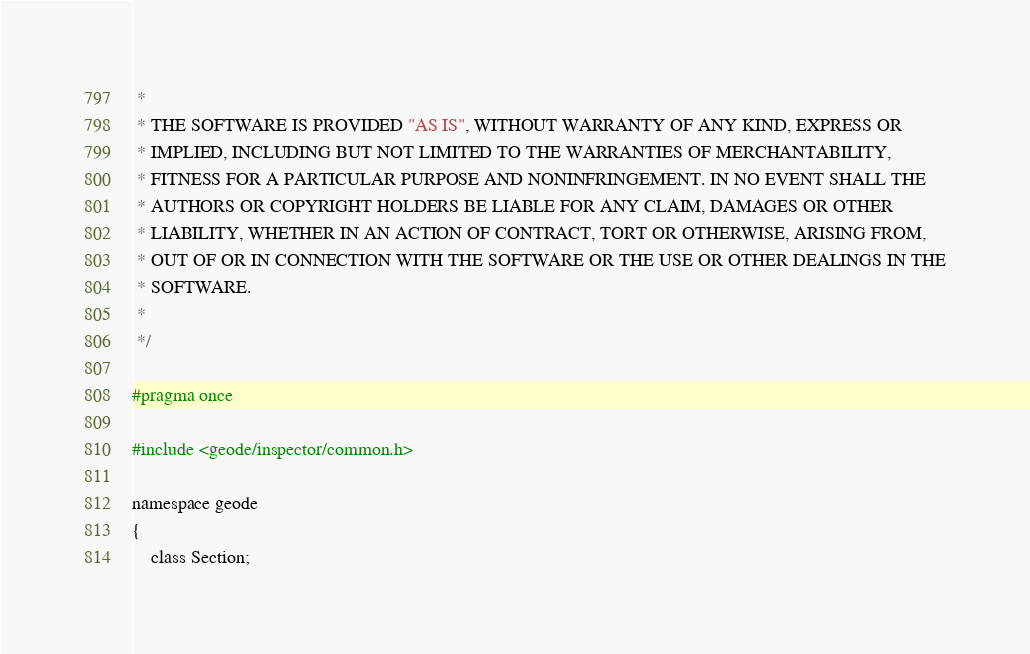Convert code to text. <code><loc_0><loc_0><loc_500><loc_500><_C_> *
 * THE SOFTWARE IS PROVIDED "AS IS", WITHOUT WARRANTY OF ANY KIND, EXPRESS OR
 * IMPLIED, INCLUDING BUT NOT LIMITED TO THE WARRANTIES OF MERCHANTABILITY,
 * FITNESS FOR A PARTICULAR PURPOSE AND NONINFRINGEMENT. IN NO EVENT SHALL THE
 * AUTHORS OR COPYRIGHT HOLDERS BE LIABLE FOR ANY CLAIM, DAMAGES OR OTHER
 * LIABILITY, WHETHER IN AN ACTION OF CONTRACT, TORT OR OTHERWISE, ARISING FROM,
 * OUT OF OR IN CONNECTION WITH THE SOFTWARE OR THE USE OR OTHER DEALINGS IN THE
 * SOFTWARE.
 *
 */

#pragma once

#include <geode/inspector/common.h>

namespace geode
{
    class Section;</code> 